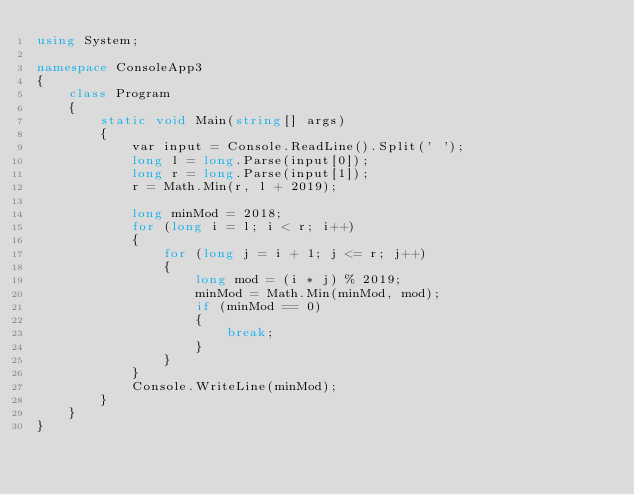Convert code to text. <code><loc_0><loc_0><loc_500><loc_500><_C#_>using System;

namespace ConsoleApp3
{
	class Program
	{
		static void Main(string[] args)
		{
			var input = Console.ReadLine().Split(' ');
			long l = long.Parse(input[0]);
			long r = long.Parse(input[1]);
			r = Math.Min(r, l + 2019);

			long minMod = 2018;
			for (long i = l; i < r; i++)
			{
				for (long j = i + 1; j <= r; j++)
				{
					long mod = (i * j) % 2019;
					minMod = Math.Min(minMod, mod);
					if (minMod == 0)
					{
						break;
					}
				}
			}
			Console.WriteLine(minMod);
		}
	}
}
</code> 